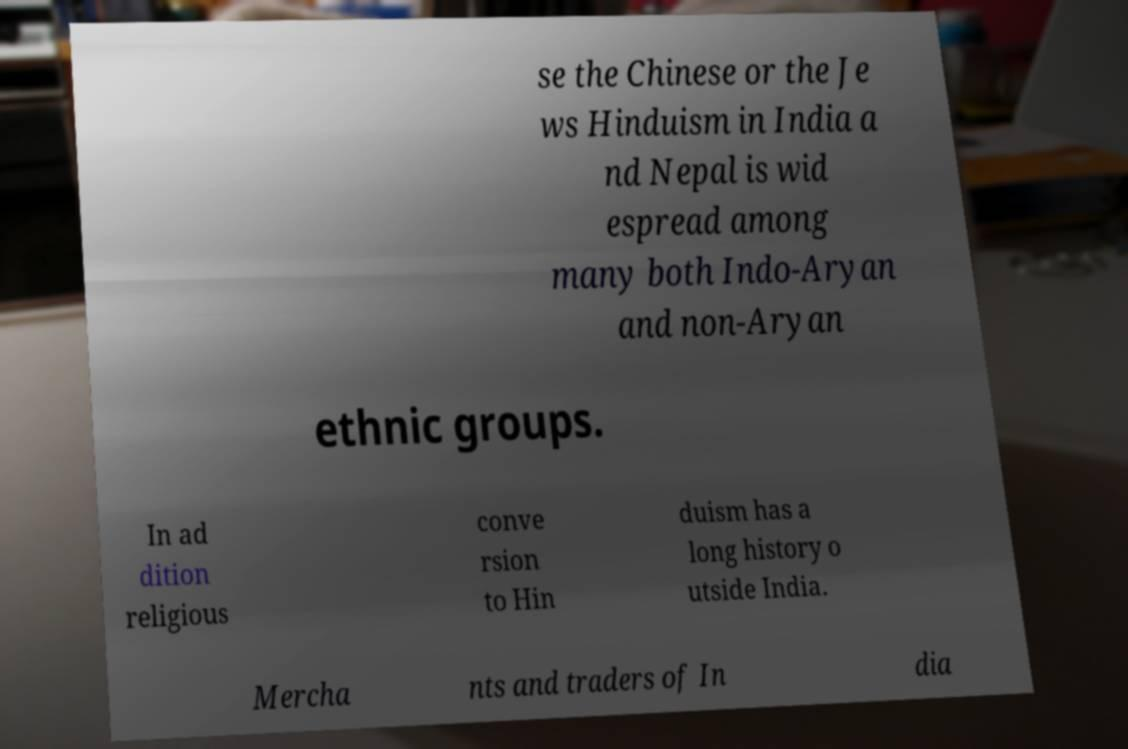I need the written content from this picture converted into text. Can you do that? se the Chinese or the Je ws Hinduism in India a nd Nepal is wid espread among many both Indo-Aryan and non-Aryan ethnic groups. In ad dition religious conve rsion to Hin duism has a long history o utside India. Mercha nts and traders of In dia 